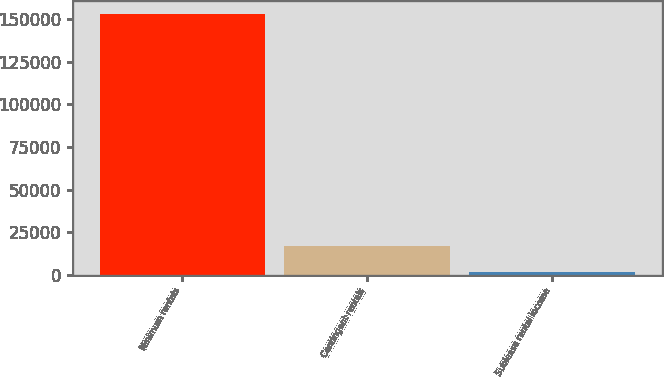Convert chart. <chart><loc_0><loc_0><loc_500><loc_500><bar_chart><fcel>Minimum rentals<fcel>Contingent rentals<fcel>Sublease rental income<nl><fcel>152935<fcel>16754.2<fcel>1623<nl></chart> 